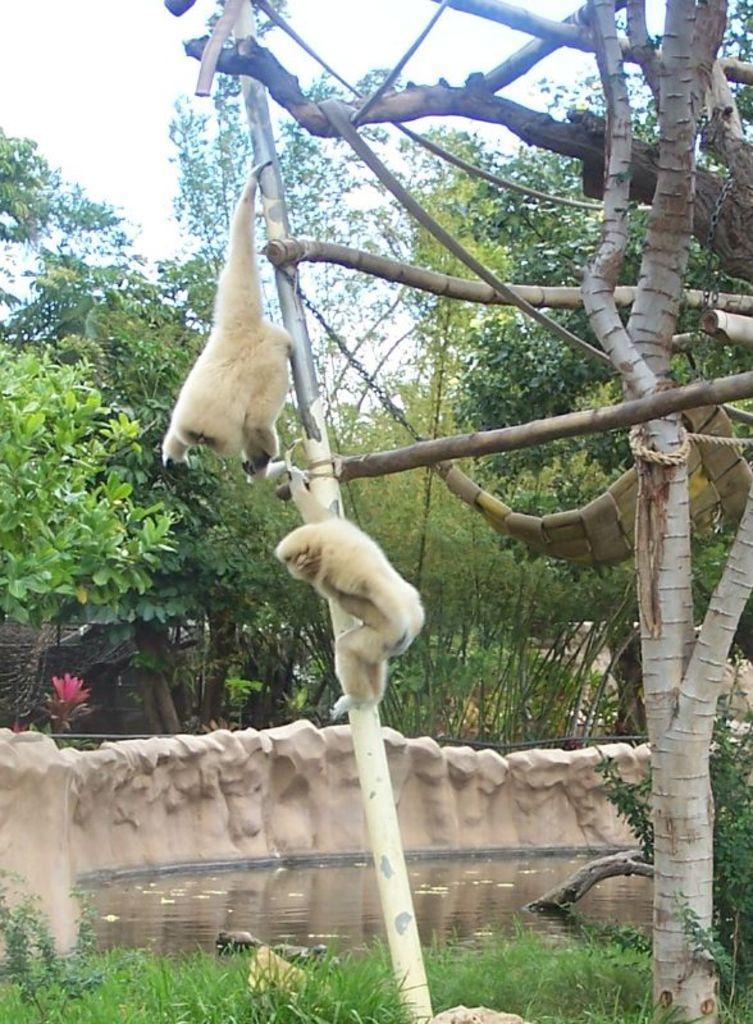How would you summarize this image in a sentence or two? At the bottom of the image there is a grass, behind the grass there is a pond. On the right side of the image there is a tree. On the tree there are two monkeys and one swing. In the background of the image there are trees and sky. 